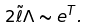<formula> <loc_0><loc_0><loc_500><loc_500>2 \tilde { \ell } \Lambda \sim e ^ { T } .</formula> 